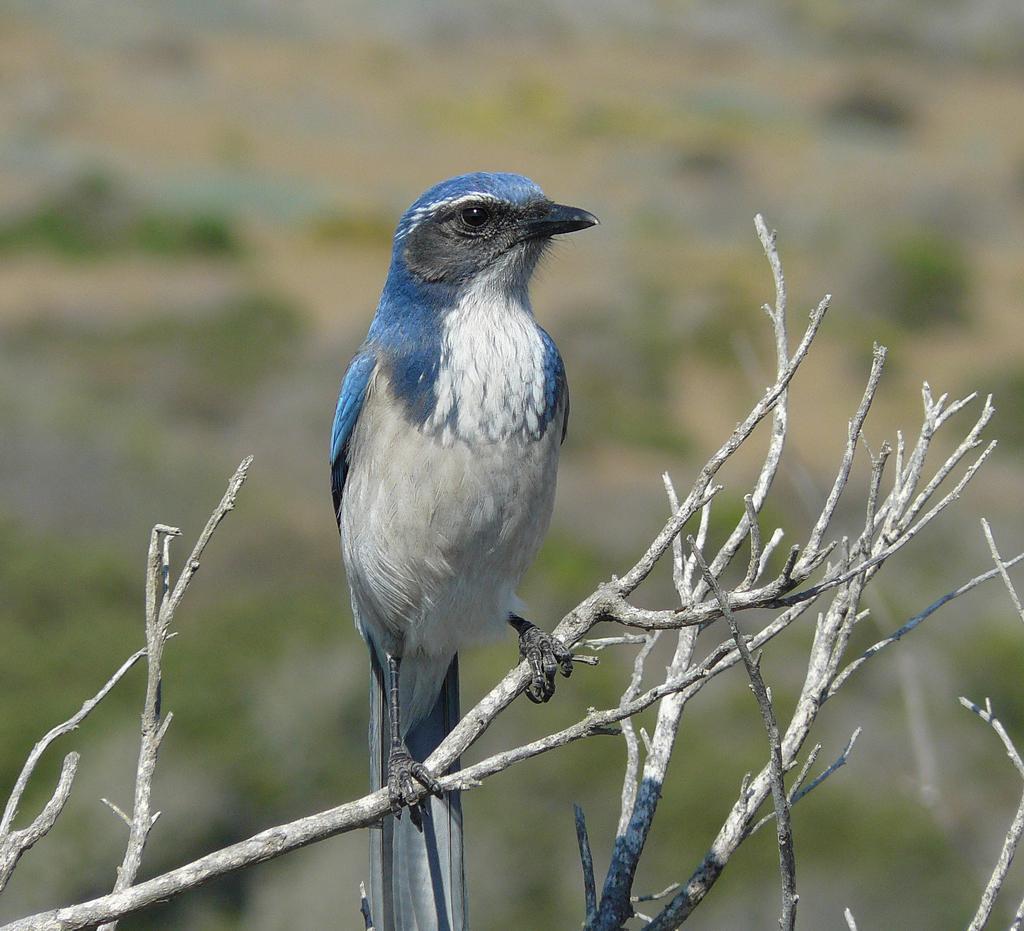What type of animal is in the image? There is a bird in the image. Where is the bird located? The bird is on a stem. In which direction is the bird looking? The bird is looking to the right side. How would you describe the background of the image? The background of the image is blurred. What type of thread is being used to sew the juice in the image? There is no thread or juice present in the image; it features a bird on a stem with a blurred background. 